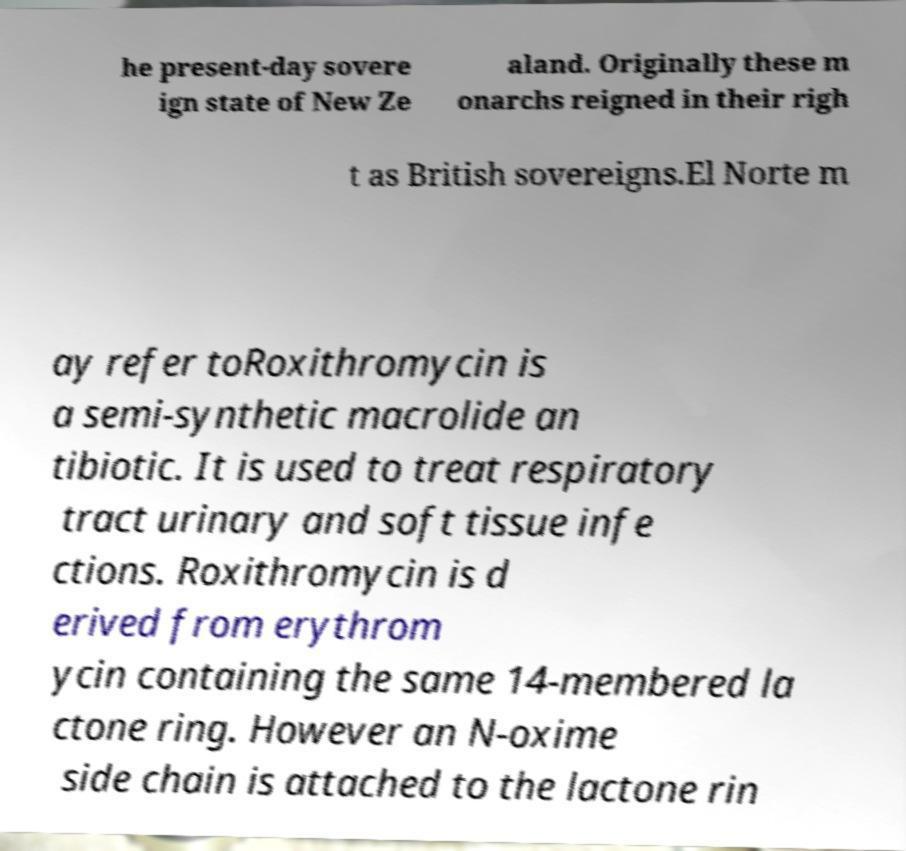Can you read and provide the text displayed in the image?This photo seems to have some interesting text. Can you extract and type it out for me? he present-day sovere ign state of New Ze aland. Originally these m onarchs reigned in their righ t as British sovereigns.El Norte m ay refer toRoxithromycin is a semi-synthetic macrolide an tibiotic. It is used to treat respiratory tract urinary and soft tissue infe ctions. Roxithromycin is d erived from erythrom ycin containing the same 14-membered la ctone ring. However an N-oxime side chain is attached to the lactone rin 